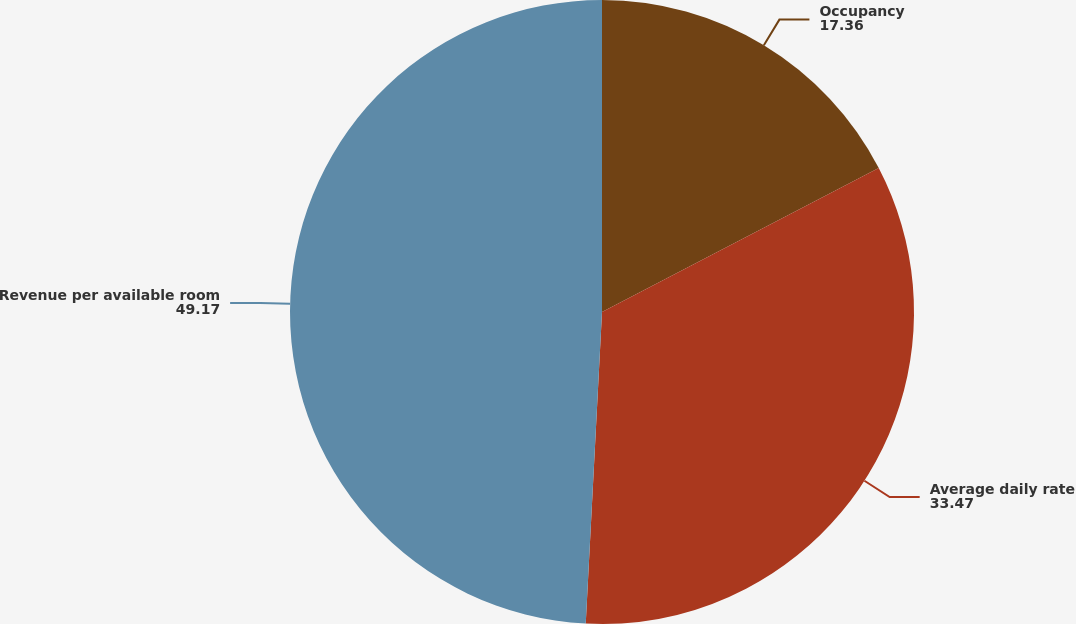<chart> <loc_0><loc_0><loc_500><loc_500><pie_chart><fcel>Occupancy<fcel>Average daily rate<fcel>Revenue per available room<nl><fcel>17.36%<fcel>33.47%<fcel>49.17%<nl></chart> 